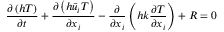Convert formula to latex. <formula><loc_0><loc_0><loc_500><loc_500>\frac { \partial \left ( h T \right ) } { \partial t } + \frac { \partial \left ( h { { { \bar { u } } } _ { i } } T \right ) } { \partial { { x } _ { i } } } - \frac { \partial } { \partial { { x } _ { i } } } \left ( h k \frac { \partial T } { \partial { { x } _ { i } } } \right ) + R = 0</formula> 